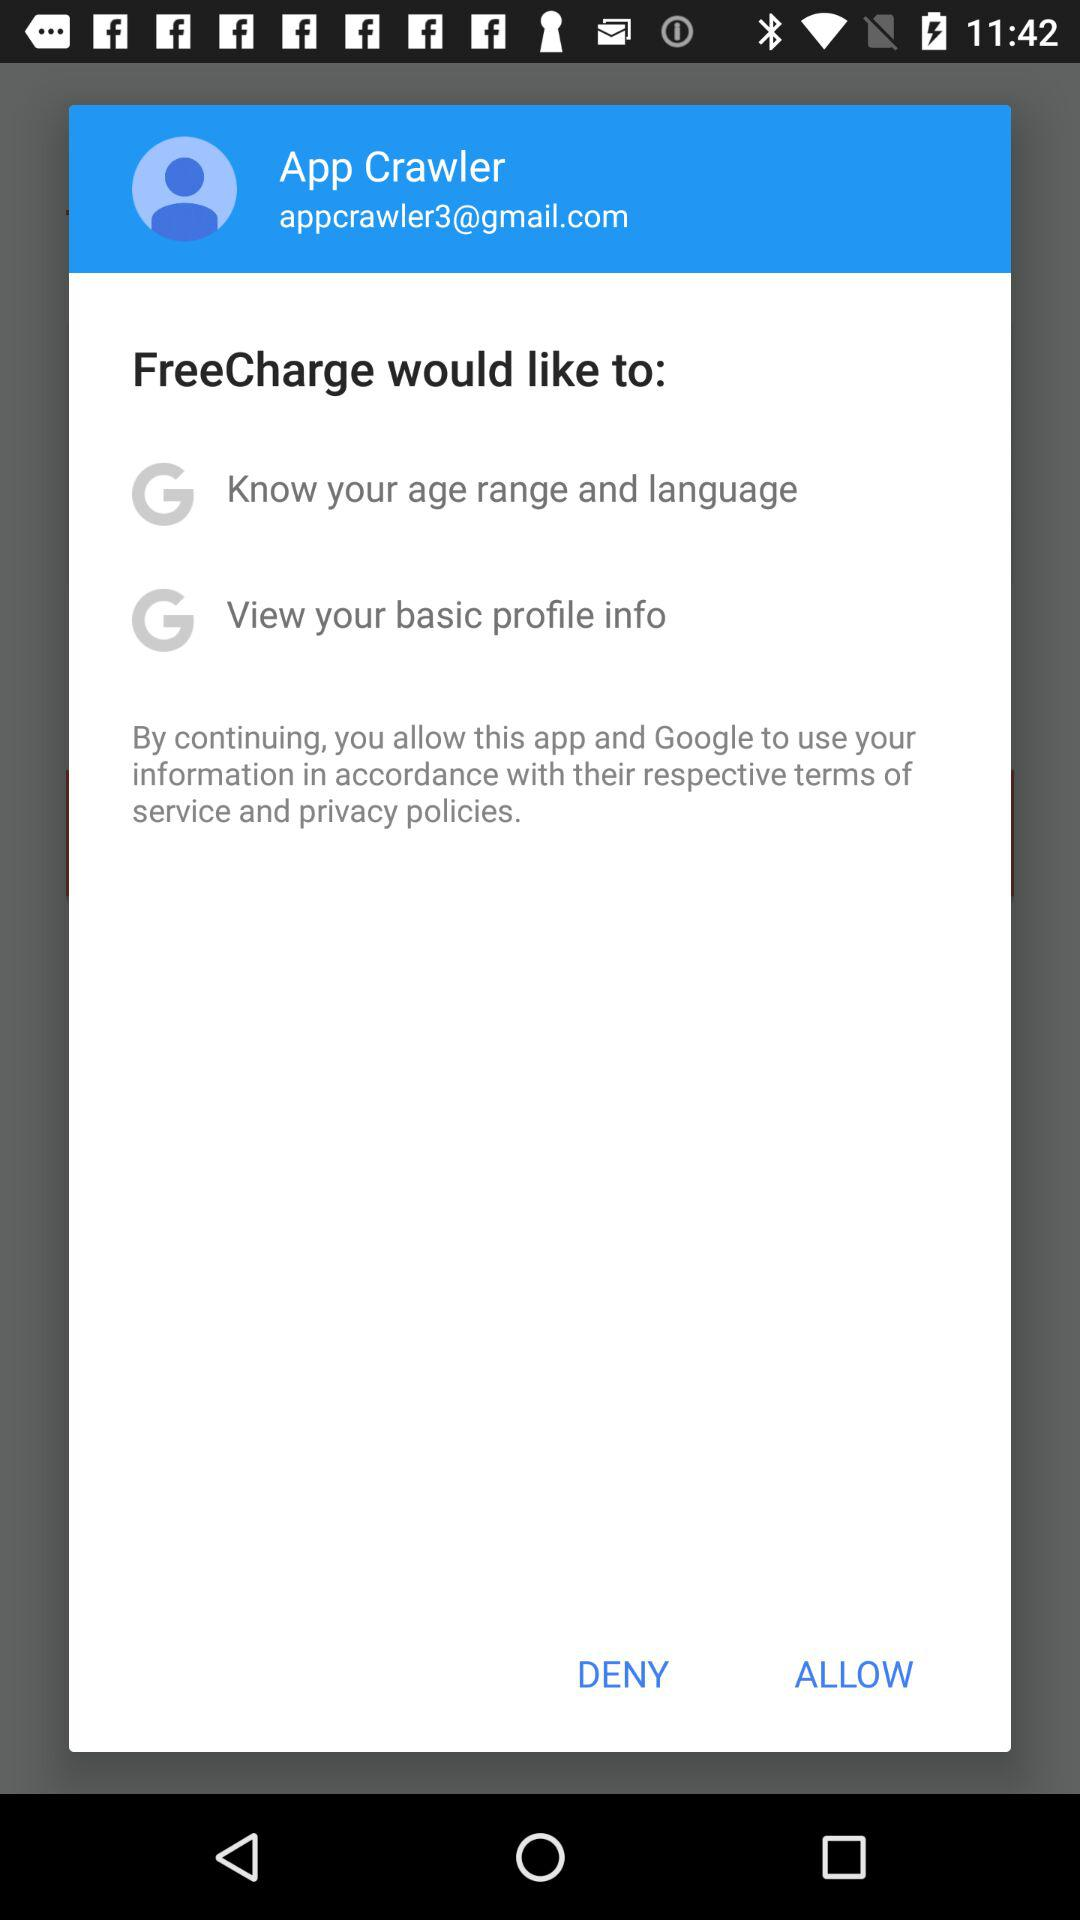What is the email address? The email address is appcrawler3@gmail.com. 